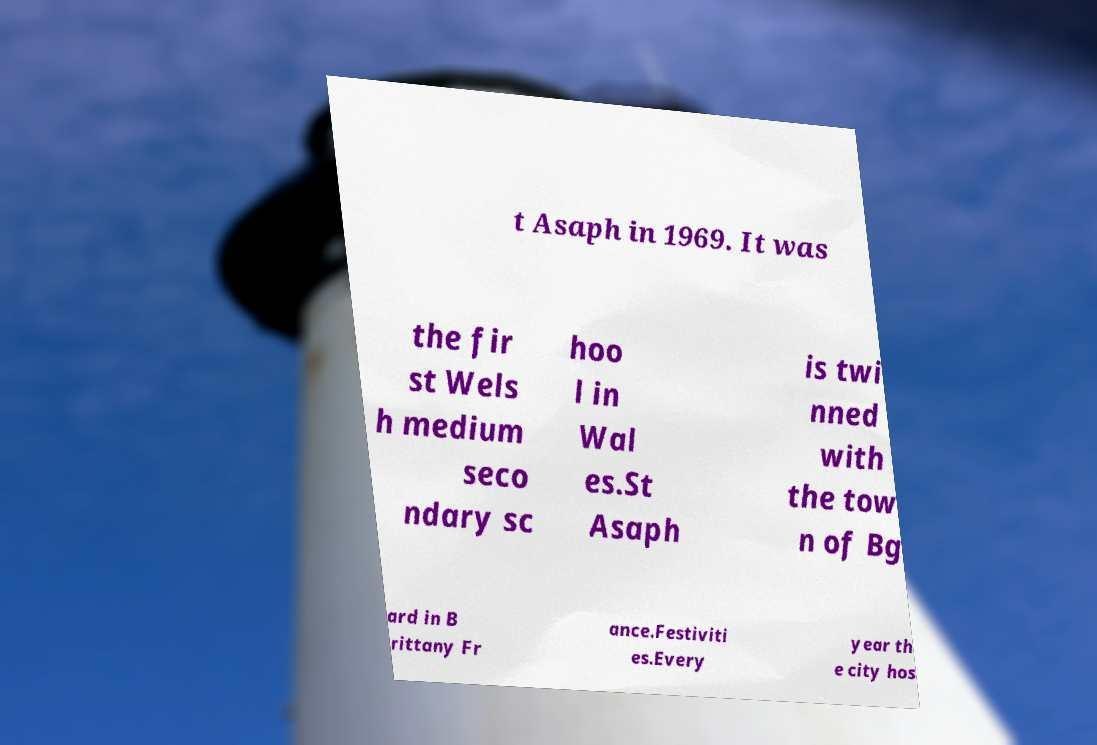Please read and relay the text visible in this image. What does it say? t Asaph in 1969. It was the fir st Wels h medium seco ndary sc hoo l in Wal es.St Asaph is twi nned with the tow n of Bg ard in B rittany Fr ance.Festiviti es.Every year th e city hos 